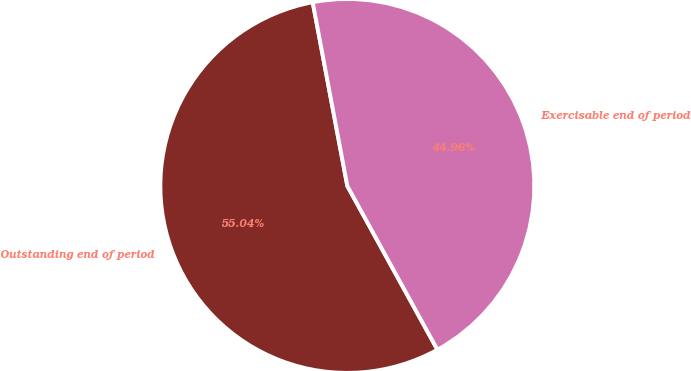<chart> <loc_0><loc_0><loc_500><loc_500><pie_chart><fcel>Outstanding end of period<fcel>Exercisable end of period<nl><fcel>55.04%<fcel>44.96%<nl></chart> 